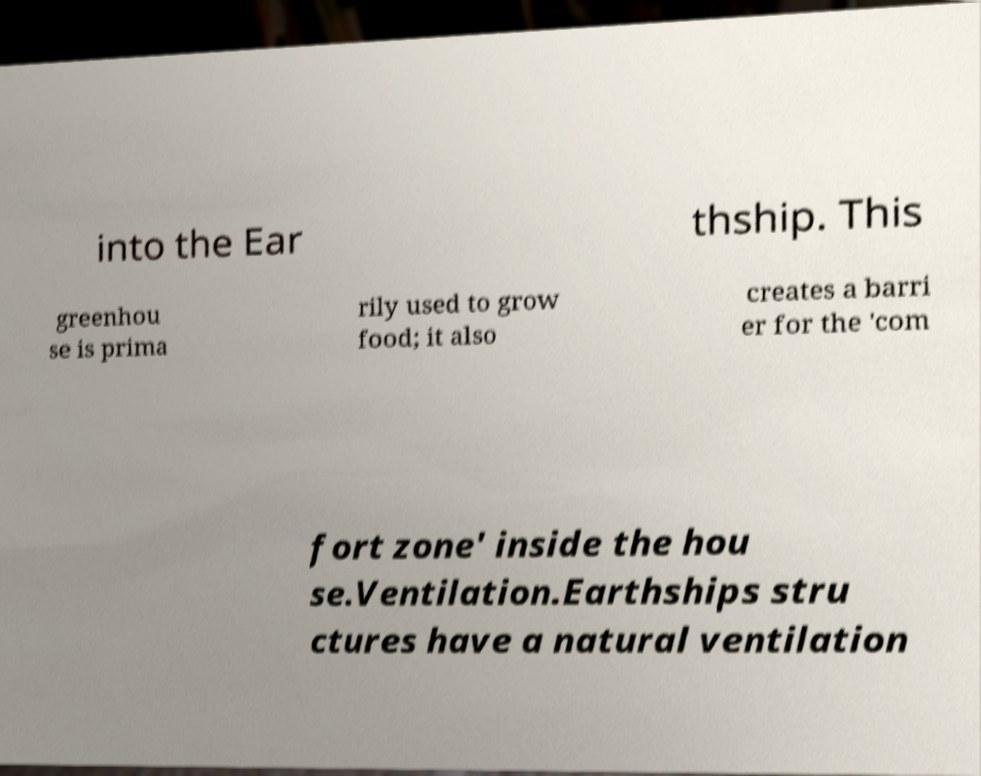What messages or text are displayed in this image? I need them in a readable, typed format. into the Ear thship. This greenhou se is prima rily used to grow food; it also creates a barri er for the 'com fort zone' inside the hou se.Ventilation.Earthships stru ctures have a natural ventilation 